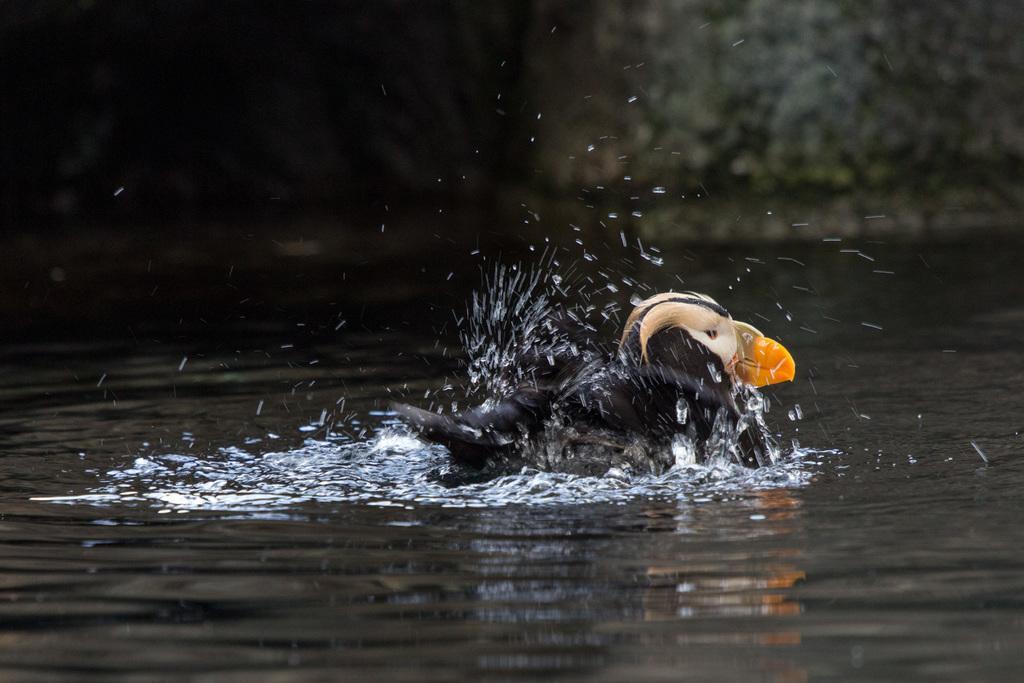Could you give a brief overview of what you see in this image? In this image I can see a bird on the water. The background of the image is blurred. 